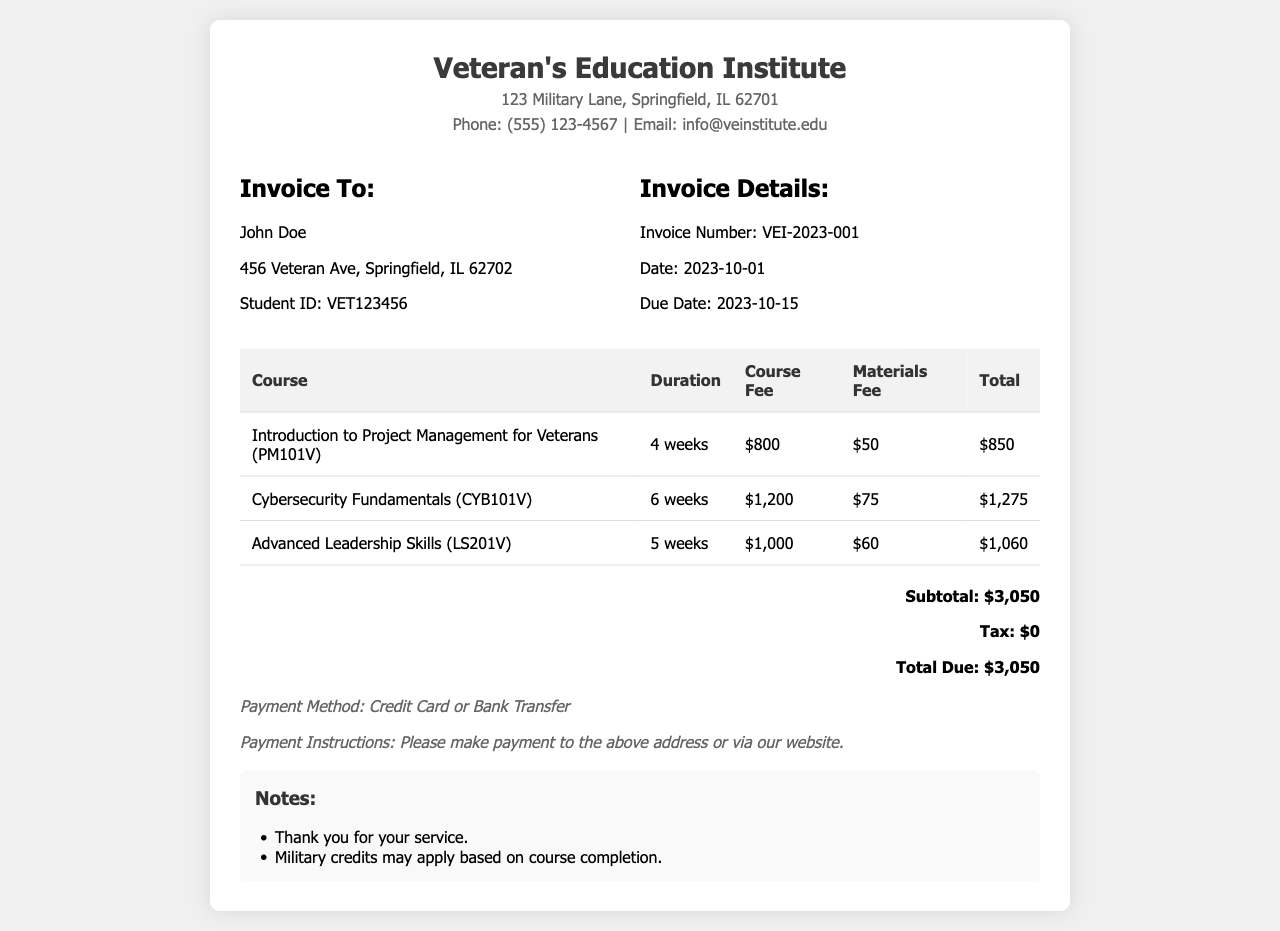what is the name of the institute? The name of the institute is stated at the top of the document as "Veteran's Education Institute."
Answer: Veteran's Education Institute who is the invoice addressed to? The invoice is addressed to the individual listed in the document, whose name is mentioned in the recipient section.
Answer: John Doe what is the due date for the invoice? The due date is provided in the invoice details section—specifically designated as the date by which payment must be made.
Answer: 2023-10-15 how many weeks does the "Cybersecurity Fundamentals" course last? The duration of the "Cybersecurity Fundamentals" course is stated in the table within the document.
Answer: 6 weeks what is the total fee for the "Advanced Leadership Skills" course? The total fee is the sum of the course fee and materials fee for "Advanced Leadership Skills," which can be found in the course details table.
Answer: $1,060 what is the subtotal amount listed in the invoice? The subtotal is clearly stated in the total section of the invoice and reflects the total course fees before tax.
Answer: $3,050 which payment methods are accepted? The accepted payment methods are mentioned in the payment terms section of the invoice, indicating how the payment can be made.
Answer: Credit Card or Bank Transfer how much is the materials fee for the "Introduction to Project Management for Veterans"? The materials fee for this specific course is listed in the invoice table under the respective column.
Answer: $50 what notes are included at the end of the invoice? The notes section contains remarks regarding military service and potential credits.
Answer: Thank you for your service. Military credits may apply based on course completion 